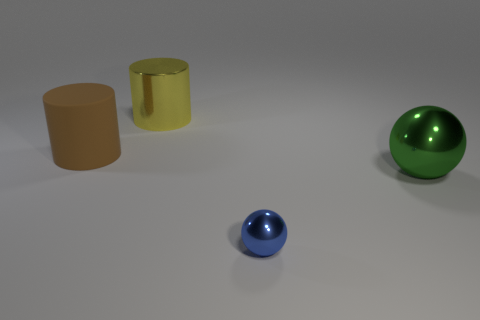Is there any other thing that has the same size as the blue shiny ball?
Keep it short and to the point. No. Is the large green sphere made of the same material as the sphere that is in front of the green shiny object?
Offer a terse response. Yes. How many brown rubber things have the same size as the green sphere?
Make the answer very short. 1. Is the number of small blue spheres behind the brown matte object less than the number of yellow metallic things?
Your answer should be compact. Yes. There is a large rubber thing; what number of yellow shiny cylinders are to the right of it?
Provide a short and direct response. 1. There is a metal ball to the left of the big object on the right side of the big metal thing that is behind the big brown rubber object; what size is it?
Your response must be concise. Small. Does the big rubber object have the same shape as the big object to the right of the yellow thing?
Your answer should be compact. No. There is a yellow cylinder that is the same material as the big ball; what size is it?
Provide a succinct answer. Large. Is there any other thing that has the same color as the tiny shiny thing?
Provide a short and direct response. No. There is a sphere that is behind the object in front of the sphere behind the blue shiny object; what is its material?
Offer a very short reply. Metal. 